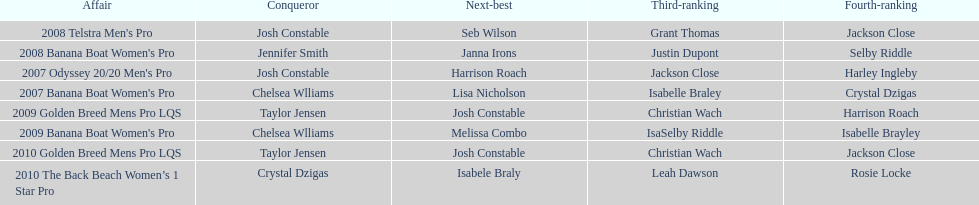Between 2007 and 2010, how many times did chelsea williams emerge as the winner? 2. 